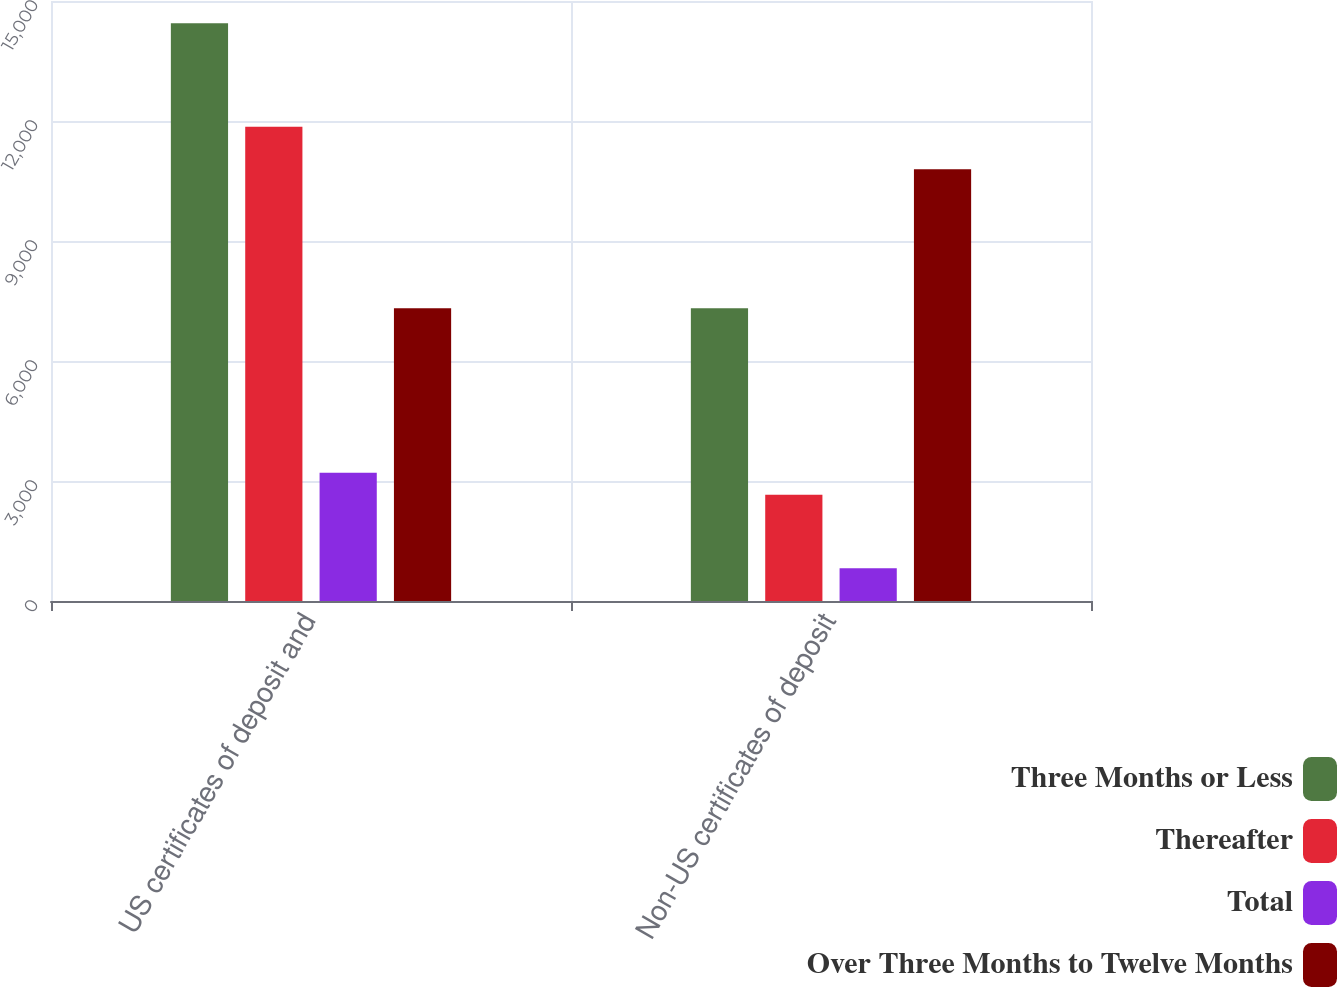<chart> <loc_0><loc_0><loc_500><loc_500><stacked_bar_chart><ecel><fcel>US certificates of deposit and<fcel>Non-US certificates of deposit<nl><fcel>Three Months or Less<fcel>14441<fcel>7317<nl><fcel>Thereafter<fcel>11855<fcel>2655<nl><fcel>Total<fcel>3209<fcel>820<nl><fcel>Over Three Months to Twelve Months<fcel>7317<fcel>10792<nl></chart> 